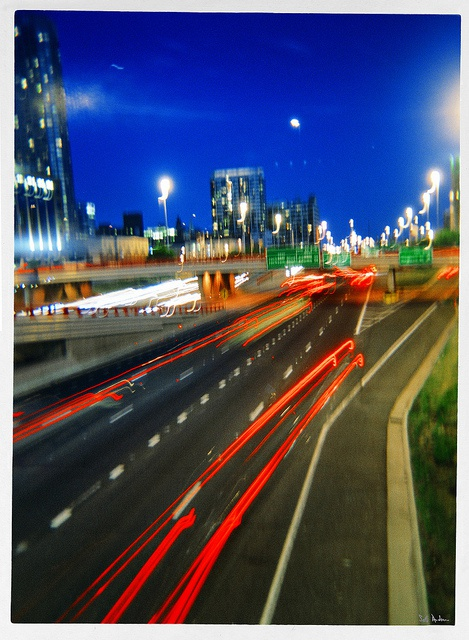Describe the objects in this image and their specific colors. I can see various objects in this image with different colors. 